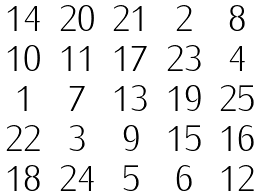Convert formula to latex. <formula><loc_0><loc_0><loc_500><loc_500>\begin{matrix} 1 4 & 2 0 & 2 1 & 2 & 8 \\ 1 0 & 1 1 & 1 7 & 2 3 & 4 \\ 1 & 7 & 1 3 & 1 9 & 2 5 \\ 2 2 & 3 & 9 & 1 5 & 1 6 \\ 1 8 & 2 4 & 5 & 6 & 1 2 \end{matrix}</formula> 